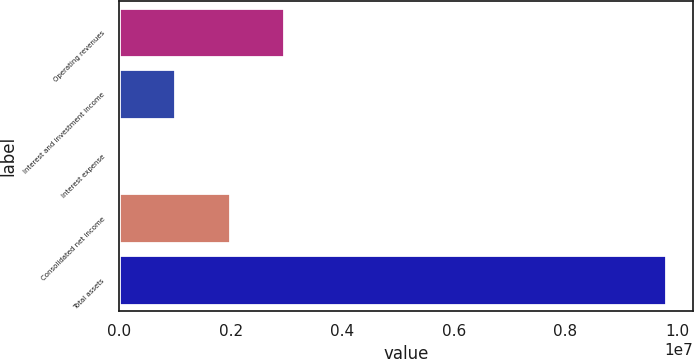Convert chart. <chart><loc_0><loc_0><loc_500><loc_500><bar_chart><fcel>Operating revenues<fcel>Interest and investment income<fcel>Interest expense<fcel>Consolidated net income<fcel>Total assets<nl><fcel>2.96211e+06<fcel>1.00941e+06<fcel>33067<fcel>1.98576e+06<fcel>9.79653e+06<nl></chart> 